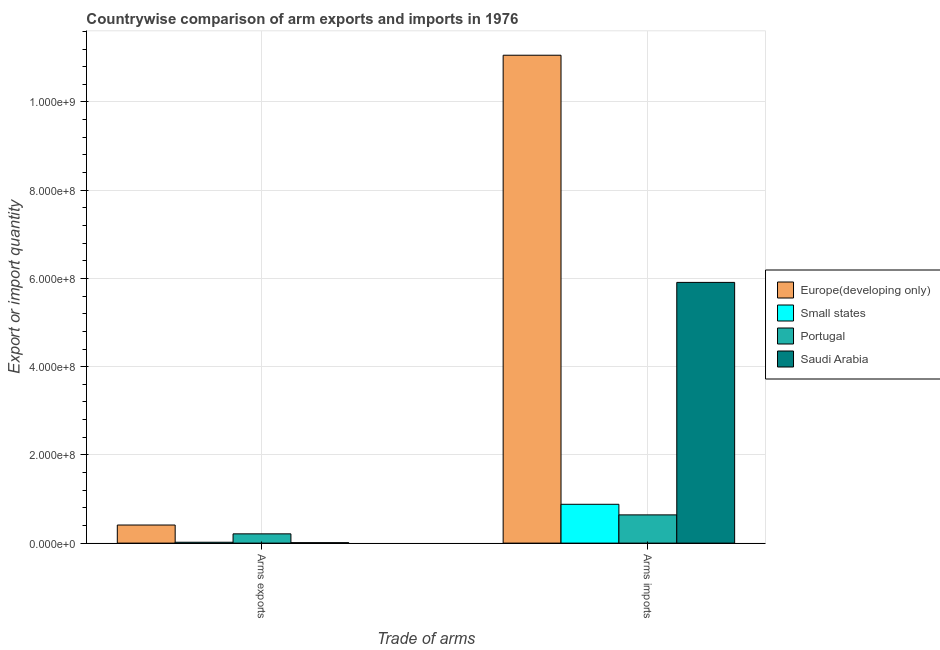Are the number of bars per tick equal to the number of legend labels?
Your response must be concise. Yes. Are the number of bars on each tick of the X-axis equal?
Offer a very short reply. Yes. What is the label of the 1st group of bars from the left?
Make the answer very short. Arms exports. What is the arms imports in Saudi Arabia?
Your response must be concise. 5.91e+08. Across all countries, what is the maximum arms exports?
Your response must be concise. 4.10e+07. Across all countries, what is the minimum arms imports?
Your answer should be very brief. 6.40e+07. In which country was the arms imports maximum?
Offer a very short reply. Europe(developing only). In which country was the arms imports minimum?
Make the answer very short. Portugal. What is the total arms exports in the graph?
Make the answer very short. 6.50e+07. What is the difference between the arms exports in Europe(developing only) and that in Portugal?
Offer a terse response. 2.00e+07. What is the difference between the arms exports in Small states and the arms imports in Portugal?
Offer a very short reply. -6.20e+07. What is the average arms imports per country?
Offer a very short reply. 4.62e+08. What is the difference between the arms imports and arms exports in Europe(developing only)?
Ensure brevity in your answer.  1.06e+09. In how many countries, is the arms exports greater than 840000000 ?
Offer a very short reply. 0. What is the ratio of the arms imports in Europe(developing only) to that in Portugal?
Make the answer very short. 17.28. Is the arms exports in Europe(developing only) less than that in Saudi Arabia?
Offer a terse response. No. In how many countries, is the arms exports greater than the average arms exports taken over all countries?
Provide a succinct answer. 2. What does the 1st bar from the left in Arms imports represents?
Your response must be concise. Europe(developing only). What does the 3rd bar from the right in Arms exports represents?
Provide a succinct answer. Small states. How many bars are there?
Ensure brevity in your answer.  8. Are all the bars in the graph horizontal?
Your answer should be very brief. No. How many countries are there in the graph?
Keep it short and to the point. 4. Are the values on the major ticks of Y-axis written in scientific E-notation?
Offer a terse response. Yes. Does the graph contain any zero values?
Keep it short and to the point. No. Does the graph contain grids?
Provide a succinct answer. Yes. Where does the legend appear in the graph?
Ensure brevity in your answer.  Center right. How are the legend labels stacked?
Your response must be concise. Vertical. What is the title of the graph?
Your answer should be compact. Countrywise comparison of arm exports and imports in 1976. Does "Serbia" appear as one of the legend labels in the graph?
Give a very brief answer. No. What is the label or title of the X-axis?
Provide a short and direct response. Trade of arms. What is the label or title of the Y-axis?
Provide a short and direct response. Export or import quantity. What is the Export or import quantity of Europe(developing only) in Arms exports?
Keep it short and to the point. 4.10e+07. What is the Export or import quantity in Small states in Arms exports?
Your response must be concise. 2.00e+06. What is the Export or import quantity of Portugal in Arms exports?
Offer a very short reply. 2.10e+07. What is the Export or import quantity in Saudi Arabia in Arms exports?
Your answer should be very brief. 1.00e+06. What is the Export or import quantity of Europe(developing only) in Arms imports?
Provide a short and direct response. 1.11e+09. What is the Export or import quantity in Small states in Arms imports?
Your answer should be compact. 8.80e+07. What is the Export or import quantity in Portugal in Arms imports?
Your answer should be compact. 6.40e+07. What is the Export or import quantity in Saudi Arabia in Arms imports?
Offer a very short reply. 5.91e+08. Across all Trade of arms, what is the maximum Export or import quantity of Europe(developing only)?
Your answer should be compact. 1.11e+09. Across all Trade of arms, what is the maximum Export or import quantity in Small states?
Give a very brief answer. 8.80e+07. Across all Trade of arms, what is the maximum Export or import quantity of Portugal?
Provide a short and direct response. 6.40e+07. Across all Trade of arms, what is the maximum Export or import quantity in Saudi Arabia?
Give a very brief answer. 5.91e+08. Across all Trade of arms, what is the minimum Export or import quantity in Europe(developing only)?
Make the answer very short. 4.10e+07. Across all Trade of arms, what is the minimum Export or import quantity of Portugal?
Your answer should be very brief. 2.10e+07. Across all Trade of arms, what is the minimum Export or import quantity in Saudi Arabia?
Ensure brevity in your answer.  1.00e+06. What is the total Export or import quantity in Europe(developing only) in the graph?
Offer a terse response. 1.15e+09. What is the total Export or import quantity in Small states in the graph?
Make the answer very short. 9.00e+07. What is the total Export or import quantity of Portugal in the graph?
Your response must be concise. 8.50e+07. What is the total Export or import quantity of Saudi Arabia in the graph?
Keep it short and to the point. 5.92e+08. What is the difference between the Export or import quantity of Europe(developing only) in Arms exports and that in Arms imports?
Offer a very short reply. -1.06e+09. What is the difference between the Export or import quantity of Small states in Arms exports and that in Arms imports?
Offer a very short reply. -8.60e+07. What is the difference between the Export or import quantity of Portugal in Arms exports and that in Arms imports?
Offer a terse response. -4.30e+07. What is the difference between the Export or import quantity of Saudi Arabia in Arms exports and that in Arms imports?
Offer a very short reply. -5.90e+08. What is the difference between the Export or import quantity in Europe(developing only) in Arms exports and the Export or import quantity in Small states in Arms imports?
Provide a succinct answer. -4.70e+07. What is the difference between the Export or import quantity of Europe(developing only) in Arms exports and the Export or import quantity of Portugal in Arms imports?
Give a very brief answer. -2.30e+07. What is the difference between the Export or import quantity in Europe(developing only) in Arms exports and the Export or import quantity in Saudi Arabia in Arms imports?
Make the answer very short. -5.50e+08. What is the difference between the Export or import quantity of Small states in Arms exports and the Export or import quantity of Portugal in Arms imports?
Ensure brevity in your answer.  -6.20e+07. What is the difference between the Export or import quantity of Small states in Arms exports and the Export or import quantity of Saudi Arabia in Arms imports?
Offer a very short reply. -5.89e+08. What is the difference between the Export or import quantity of Portugal in Arms exports and the Export or import quantity of Saudi Arabia in Arms imports?
Your response must be concise. -5.70e+08. What is the average Export or import quantity in Europe(developing only) per Trade of arms?
Make the answer very short. 5.74e+08. What is the average Export or import quantity in Small states per Trade of arms?
Keep it short and to the point. 4.50e+07. What is the average Export or import quantity of Portugal per Trade of arms?
Make the answer very short. 4.25e+07. What is the average Export or import quantity in Saudi Arabia per Trade of arms?
Your answer should be very brief. 2.96e+08. What is the difference between the Export or import quantity in Europe(developing only) and Export or import quantity in Small states in Arms exports?
Give a very brief answer. 3.90e+07. What is the difference between the Export or import quantity of Europe(developing only) and Export or import quantity of Saudi Arabia in Arms exports?
Your response must be concise. 4.00e+07. What is the difference between the Export or import quantity in Small states and Export or import quantity in Portugal in Arms exports?
Offer a terse response. -1.90e+07. What is the difference between the Export or import quantity in Europe(developing only) and Export or import quantity in Small states in Arms imports?
Your response must be concise. 1.02e+09. What is the difference between the Export or import quantity in Europe(developing only) and Export or import quantity in Portugal in Arms imports?
Offer a terse response. 1.04e+09. What is the difference between the Export or import quantity of Europe(developing only) and Export or import quantity of Saudi Arabia in Arms imports?
Your answer should be compact. 5.15e+08. What is the difference between the Export or import quantity of Small states and Export or import quantity of Portugal in Arms imports?
Give a very brief answer. 2.40e+07. What is the difference between the Export or import quantity of Small states and Export or import quantity of Saudi Arabia in Arms imports?
Ensure brevity in your answer.  -5.03e+08. What is the difference between the Export or import quantity of Portugal and Export or import quantity of Saudi Arabia in Arms imports?
Make the answer very short. -5.27e+08. What is the ratio of the Export or import quantity in Europe(developing only) in Arms exports to that in Arms imports?
Provide a succinct answer. 0.04. What is the ratio of the Export or import quantity of Small states in Arms exports to that in Arms imports?
Make the answer very short. 0.02. What is the ratio of the Export or import quantity in Portugal in Arms exports to that in Arms imports?
Ensure brevity in your answer.  0.33. What is the ratio of the Export or import quantity in Saudi Arabia in Arms exports to that in Arms imports?
Offer a very short reply. 0. What is the difference between the highest and the second highest Export or import quantity in Europe(developing only)?
Provide a short and direct response. 1.06e+09. What is the difference between the highest and the second highest Export or import quantity of Small states?
Provide a succinct answer. 8.60e+07. What is the difference between the highest and the second highest Export or import quantity of Portugal?
Provide a succinct answer. 4.30e+07. What is the difference between the highest and the second highest Export or import quantity in Saudi Arabia?
Provide a succinct answer. 5.90e+08. What is the difference between the highest and the lowest Export or import quantity in Europe(developing only)?
Provide a short and direct response. 1.06e+09. What is the difference between the highest and the lowest Export or import quantity in Small states?
Your answer should be very brief. 8.60e+07. What is the difference between the highest and the lowest Export or import quantity in Portugal?
Provide a short and direct response. 4.30e+07. What is the difference between the highest and the lowest Export or import quantity of Saudi Arabia?
Your response must be concise. 5.90e+08. 